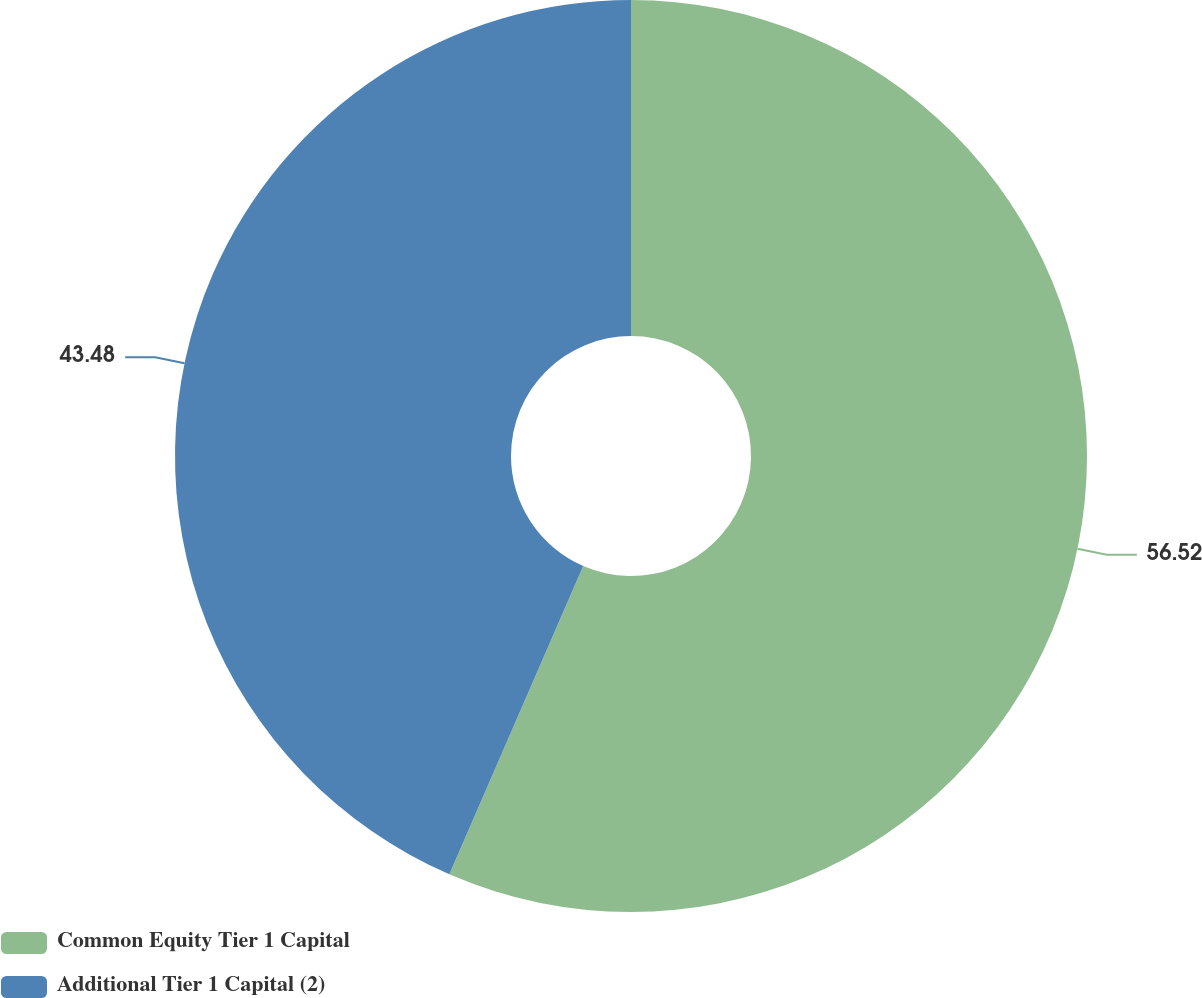<chart> <loc_0><loc_0><loc_500><loc_500><pie_chart><fcel>Common Equity Tier 1 Capital<fcel>Additional Tier 1 Capital (2)<nl><fcel>56.52%<fcel>43.48%<nl></chart> 